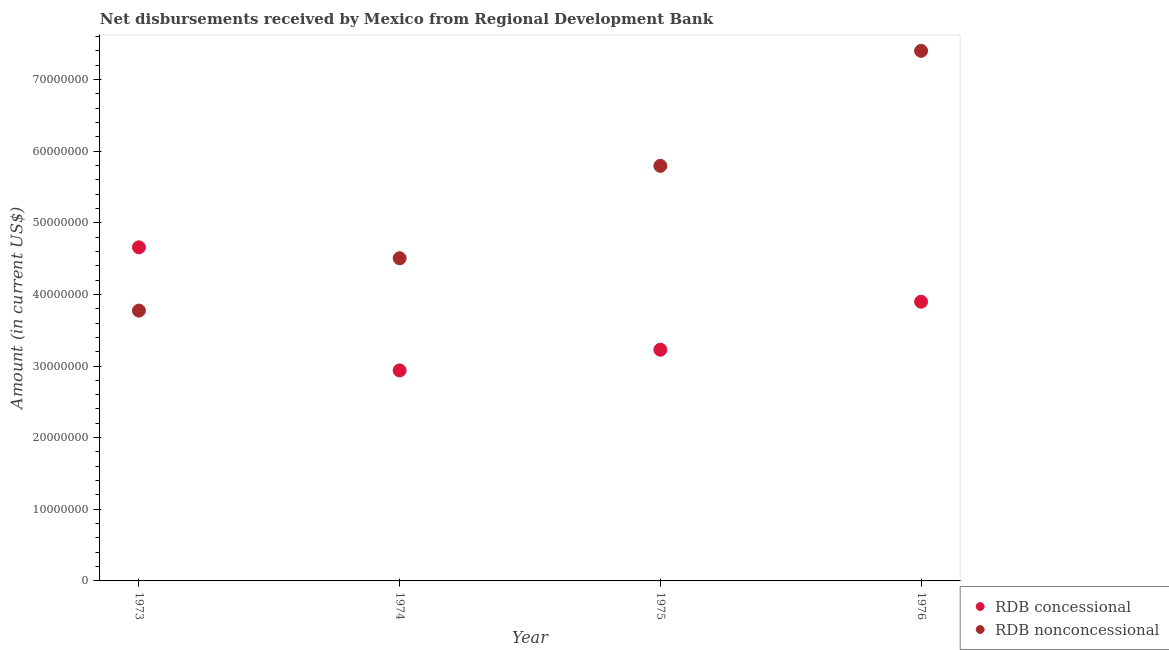How many different coloured dotlines are there?
Your answer should be very brief. 2. What is the net concessional disbursements from rdb in 1974?
Make the answer very short. 2.94e+07. Across all years, what is the maximum net non concessional disbursements from rdb?
Offer a terse response. 7.40e+07. Across all years, what is the minimum net non concessional disbursements from rdb?
Your response must be concise. 3.77e+07. In which year was the net concessional disbursements from rdb minimum?
Your answer should be compact. 1974. What is the total net non concessional disbursements from rdb in the graph?
Your answer should be very brief. 2.15e+08. What is the difference between the net non concessional disbursements from rdb in 1973 and that in 1974?
Your answer should be very brief. -7.31e+06. What is the difference between the net concessional disbursements from rdb in 1975 and the net non concessional disbursements from rdb in 1976?
Your answer should be compact. -4.17e+07. What is the average net concessional disbursements from rdb per year?
Provide a succinct answer. 3.68e+07. In the year 1976, what is the difference between the net concessional disbursements from rdb and net non concessional disbursements from rdb?
Provide a short and direct response. -3.50e+07. What is the ratio of the net concessional disbursements from rdb in 1973 to that in 1974?
Provide a short and direct response. 1.58. Is the net concessional disbursements from rdb in 1973 less than that in 1976?
Keep it short and to the point. No. Is the difference between the net concessional disbursements from rdb in 1973 and 1974 greater than the difference between the net non concessional disbursements from rdb in 1973 and 1974?
Offer a very short reply. Yes. What is the difference between the highest and the second highest net concessional disbursements from rdb?
Provide a short and direct response. 7.59e+06. What is the difference between the highest and the lowest net non concessional disbursements from rdb?
Offer a very short reply. 3.63e+07. Is the sum of the net concessional disbursements from rdb in 1973 and 1976 greater than the maximum net non concessional disbursements from rdb across all years?
Give a very brief answer. Yes. Does the graph contain any zero values?
Keep it short and to the point. No. What is the title of the graph?
Provide a succinct answer. Net disbursements received by Mexico from Regional Development Bank. Does "Travel services" appear as one of the legend labels in the graph?
Your answer should be compact. No. What is the Amount (in current US$) of RDB concessional in 1973?
Your response must be concise. 4.66e+07. What is the Amount (in current US$) of RDB nonconcessional in 1973?
Provide a succinct answer. 3.77e+07. What is the Amount (in current US$) of RDB concessional in 1974?
Offer a very short reply. 2.94e+07. What is the Amount (in current US$) of RDB nonconcessional in 1974?
Ensure brevity in your answer.  4.50e+07. What is the Amount (in current US$) in RDB concessional in 1975?
Keep it short and to the point. 3.23e+07. What is the Amount (in current US$) of RDB nonconcessional in 1975?
Your answer should be compact. 5.79e+07. What is the Amount (in current US$) of RDB concessional in 1976?
Offer a very short reply. 3.90e+07. What is the Amount (in current US$) in RDB nonconcessional in 1976?
Your answer should be compact. 7.40e+07. Across all years, what is the maximum Amount (in current US$) in RDB concessional?
Your answer should be compact. 4.66e+07. Across all years, what is the maximum Amount (in current US$) in RDB nonconcessional?
Make the answer very short. 7.40e+07. Across all years, what is the minimum Amount (in current US$) of RDB concessional?
Provide a short and direct response. 2.94e+07. Across all years, what is the minimum Amount (in current US$) in RDB nonconcessional?
Make the answer very short. 3.77e+07. What is the total Amount (in current US$) of RDB concessional in the graph?
Keep it short and to the point. 1.47e+08. What is the total Amount (in current US$) of RDB nonconcessional in the graph?
Ensure brevity in your answer.  2.15e+08. What is the difference between the Amount (in current US$) in RDB concessional in 1973 and that in 1974?
Your response must be concise. 1.72e+07. What is the difference between the Amount (in current US$) in RDB nonconcessional in 1973 and that in 1974?
Give a very brief answer. -7.31e+06. What is the difference between the Amount (in current US$) of RDB concessional in 1973 and that in 1975?
Provide a short and direct response. 1.43e+07. What is the difference between the Amount (in current US$) of RDB nonconcessional in 1973 and that in 1975?
Provide a short and direct response. -2.02e+07. What is the difference between the Amount (in current US$) of RDB concessional in 1973 and that in 1976?
Provide a short and direct response. 7.59e+06. What is the difference between the Amount (in current US$) of RDB nonconcessional in 1973 and that in 1976?
Offer a terse response. -3.63e+07. What is the difference between the Amount (in current US$) in RDB concessional in 1974 and that in 1975?
Your answer should be compact. -2.89e+06. What is the difference between the Amount (in current US$) in RDB nonconcessional in 1974 and that in 1975?
Make the answer very short. -1.29e+07. What is the difference between the Amount (in current US$) in RDB concessional in 1974 and that in 1976?
Provide a succinct answer. -9.60e+06. What is the difference between the Amount (in current US$) in RDB nonconcessional in 1974 and that in 1976?
Provide a short and direct response. -2.90e+07. What is the difference between the Amount (in current US$) of RDB concessional in 1975 and that in 1976?
Provide a short and direct response. -6.70e+06. What is the difference between the Amount (in current US$) in RDB nonconcessional in 1975 and that in 1976?
Give a very brief answer. -1.61e+07. What is the difference between the Amount (in current US$) in RDB concessional in 1973 and the Amount (in current US$) in RDB nonconcessional in 1974?
Provide a short and direct response. 1.52e+06. What is the difference between the Amount (in current US$) in RDB concessional in 1973 and the Amount (in current US$) in RDB nonconcessional in 1975?
Your answer should be compact. -1.14e+07. What is the difference between the Amount (in current US$) in RDB concessional in 1973 and the Amount (in current US$) in RDB nonconcessional in 1976?
Your answer should be very brief. -2.74e+07. What is the difference between the Amount (in current US$) in RDB concessional in 1974 and the Amount (in current US$) in RDB nonconcessional in 1975?
Your answer should be very brief. -2.86e+07. What is the difference between the Amount (in current US$) in RDB concessional in 1974 and the Amount (in current US$) in RDB nonconcessional in 1976?
Keep it short and to the point. -4.46e+07. What is the difference between the Amount (in current US$) in RDB concessional in 1975 and the Amount (in current US$) in RDB nonconcessional in 1976?
Give a very brief answer. -4.17e+07. What is the average Amount (in current US$) in RDB concessional per year?
Ensure brevity in your answer.  3.68e+07. What is the average Amount (in current US$) in RDB nonconcessional per year?
Provide a short and direct response. 5.37e+07. In the year 1973, what is the difference between the Amount (in current US$) of RDB concessional and Amount (in current US$) of RDB nonconcessional?
Offer a terse response. 8.83e+06. In the year 1974, what is the difference between the Amount (in current US$) in RDB concessional and Amount (in current US$) in RDB nonconcessional?
Give a very brief answer. -1.57e+07. In the year 1975, what is the difference between the Amount (in current US$) of RDB concessional and Amount (in current US$) of RDB nonconcessional?
Provide a short and direct response. -2.57e+07. In the year 1976, what is the difference between the Amount (in current US$) of RDB concessional and Amount (in current US$) of RDB nonconcessional?
Offer a very short reply. -3.50e+07. What is the ratio of the Amount (in current US$) of RDB concessional in 1973 to that in 1974?
Your response must be concise. 1.58. What is the ratio of the Amount (in current US$) of RDB nonconcessional in 1973 to that in 1974?
Your answer should be compact. 0.84. What is the ratio of the Amount (in current US$) of RDB concessional in 1973 to that in 1975?
Give a very brief answer. 1.44. What is the ratio of the Amount (in current US$) in RDB nonconcessional in 1973 to that in 1975?
Provide a succinct answer. 0.65. What is the ratio of the Amount (in current US$) of RDB concessional in 1973 to that in 1976?
Your answer should be very brief. 1.19. What is the ratio of the Amount (in current US$) in RDB nonconcessional in 1973 to that in 1976?
Offer a very short reply. 0.51. What is the ratio of the Amount (in current US$) in RDB concessional in 1974 to that in 1975?
Your answer should be very brief. 0.91. What is the ratio of the Amount (in current US$) in RDB nonconcessional in 1974 to that in 1975?
Provide a short and direct response. 0.78. What is the ratio of the Amount (in current US$) in RDB concessional in 1974 to that in 1976?
Your answer should be compact. 0.75. What is the ratio of the Amount (in current US$) in RDB nonconcessional in 1974 to that in 1976?
Make the answer very short. 0.61. What is the ratio of the Amount (in current US$) in RDB concessional in 1975 to that in 1976?
Offer a terse response. 0.83. What is the ratio of the Amount (in current US$) in RDB nonconcessional in 1975 to that in 1976?
Make the answer very short. 0.78. What is the difference between the highest and the second highest Amount (in current US$) in RDB concessional?
Provide a short and direct response. 7.59e+06. What is the difference between the highest and the second highest Amount (in current US$) in RDB nonconcessional?
Your answer should be compact. 1.61e+07. What is the difference between the highest and the lowest Amount (in current US$) in RDB concessional?
Offer a very short reply. 1.72e+07. What is the difference between the highest and the lowest Amount (in current US$) of RDB nonconcessional?
Ensure brevity in your answer.  3.63e+07. 